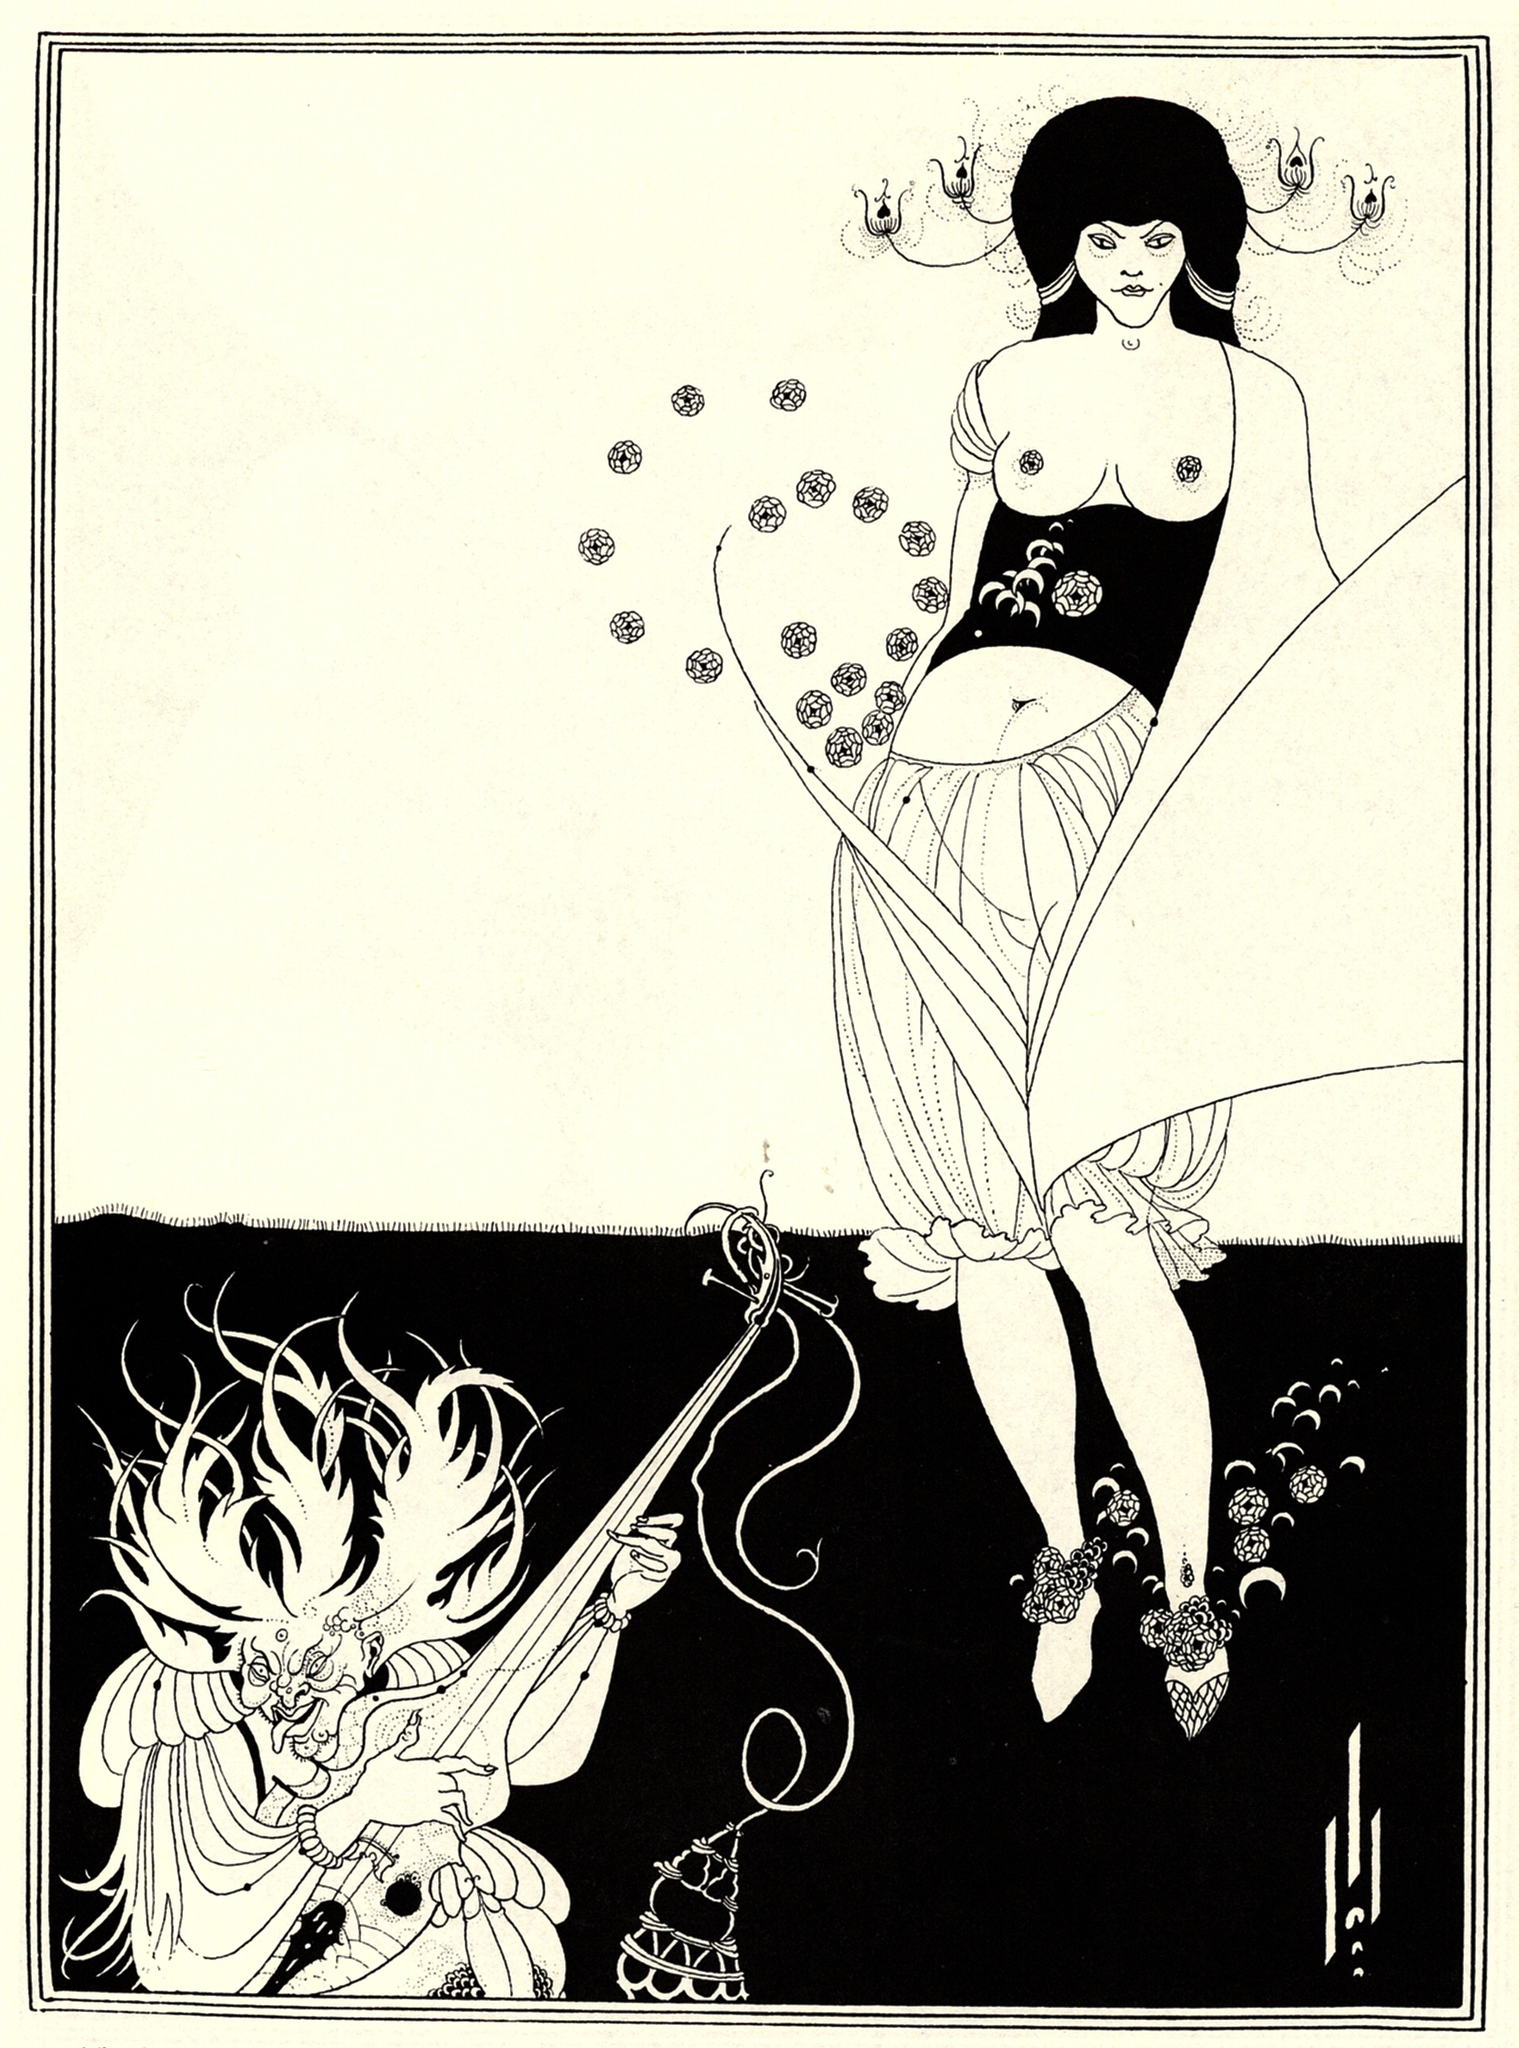What's the symbolism behind the objects the characters are holding? The objects held by the characters in the image can be rich with symbolic meaning. The woman holds a long, thin object which might represent a wand or scepter, symbolizing power, wisdom, or guidance. Her garment, filled with floral patterns, could hint at fertility, beauty, and the nurturing aspects of nature.

The dragon, on the other hand, holds a censer and a sword. The censer, often used in rituals, could symbolize spirituality, purification, and a connection to divine elements. The sword traditionally stands for power, courage, and protection. Together, the combination of these objects suggests a balance of spiritual and temporal authority, merging the mystical with the martial. This blend of symbolism invites the audience to explore the deeper meanings and themes that underline the scene, such as the interplay between delicate beauty and fierce strength. 